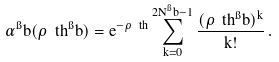<formula> <loc_0><loc_0><loc_500><loc_500>\alpha ^ { \i } b ( \rho _ { \ } t h ^ { \i } b ) = e ^ { - \rho _ { \ } t h } \sum _ { k = 0 } ^ { 2 N ^ { \i } b - 1 } \frac { ( \rho _ { \ } t h ^ { \i } b ) ^ { k } } { k ! } \, .</formula> 